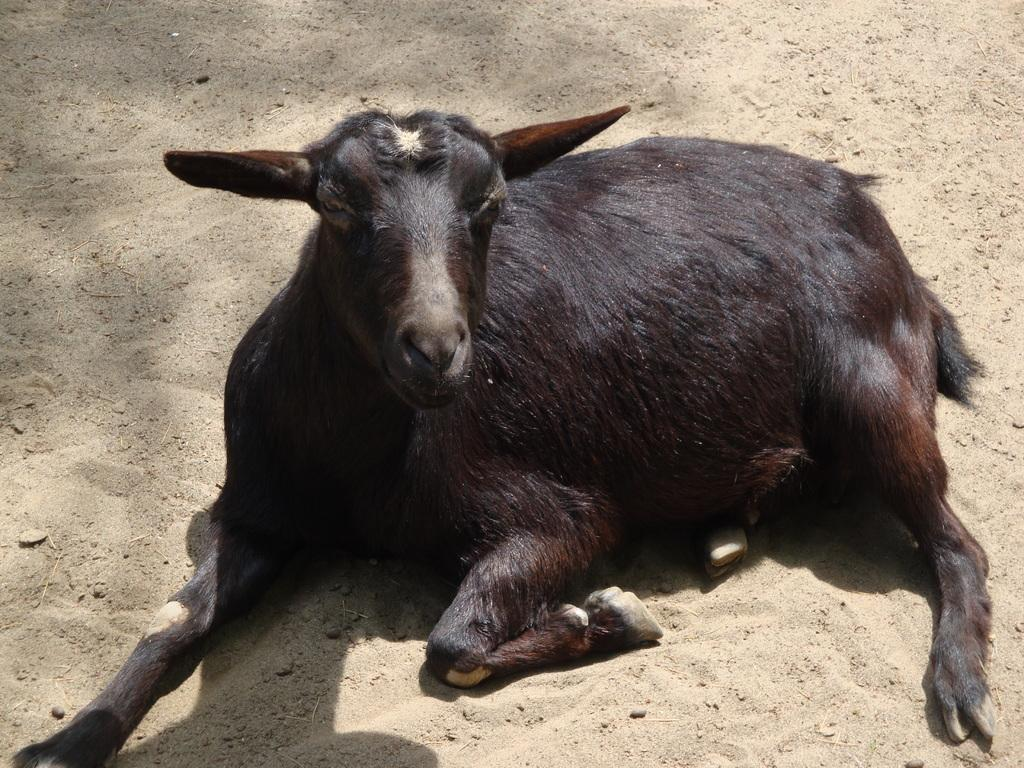What animal is present in the image? There is a goat in the image. Where is the goat located in the image? The goat is on the ground. What is the goat's temper like in the image? There is no information about the goat's temper in the image. 